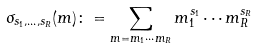Convert formula to latex. <formula><loc_0><loc_0><loc_500><loc_500>\sigma _ { s _ { 1 } , \dots , s _ { R } } ( m ) \colon = \sum _ { m = m _ { 1 } \cdots m _ { R } } m _ { 1 } ^ { s _ { 1 } } \cdots m _ { R } ^ { s _ { R } }</formula> 